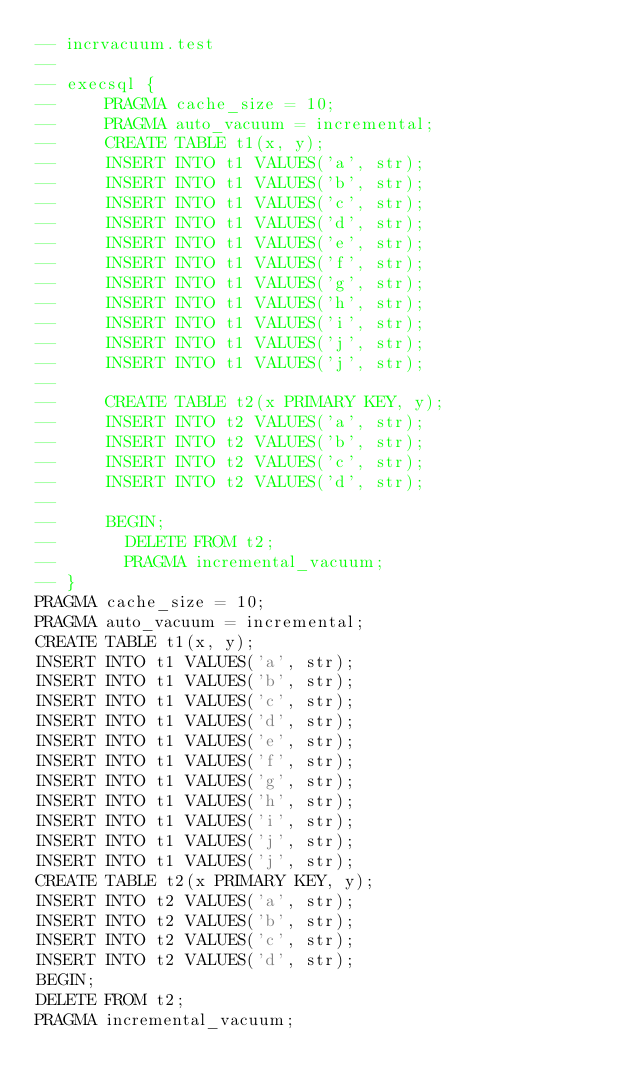<code> <loc_0><loc_0><loc_500><loc_500><_SQL_>-- incrvacuum.test
-- 
-- execsql {
--     PRAGMA cache_size = 10;
--     PRAGMA auto_vacuum = incremental;
--     CREATE TABLE t1(x, y);
--     INSERT INTO t1 VALUES('a', str);
--     INSERT INTO t1 VALUES('b', str);
--     INSERT INTO t1 VALUES('c', str);
--     INSERT INTO t1 VALUES('d', str);
--     INSERT INTO t1 VALUES('e', str);
--     INSERT INTO t1 VALUES('f', str);
--     INSERT INTO t1 VALUES('g', str);
--     INSERT INTO t1 VALUES('h', str);
--     INSERT INTO t1 VALUES('i', str);
--     INSERT INTO t1 VALUES('j', str);
--     INSERT INTO t1 VALUES('j', str);
-- 
--     CREATE TABLE t2(x PRIMARY KEY, y);
--     INSERT INTO t2 VALUES('a', str);
--     INSERT INTO t2 VALUES('b', str);
--     INSERT INTO t2 VALUES('c', str);
--     INSERT INTO t2 VALUES('d', str);
-- 
--     BEGIN;
--       DELETE FROM t2;
--       PRAGMA incremental_vacuum;
-- }
PRAGMA cache_size = 10;
PRAGMA auto_vacuum = incremental;
CREATE TABLE t1(x, y);
INSERT INTO t1 VALUES('a', str);
INSERT INTO t1 VALUES('b', str);
INSERT INTO t1 VALUES('c', str);
INSERT INTO t1 VALUES('d', str);
INSERT INTO t1 VALUES('e', str);
INSERT INTO t1 VALUES('f', str);
INSERT INTO t1 VALUES('g', str);
INSERT INTO t1 VALUES('h', str);
INSERT INTO t1 VALUES('i', str);
INSERT INTO t1 VALUES('j', str);
INSERT INTO t1 VALUES('j', str);
CREATE TABLE t2(x PRIMARY KEY, y);
INSERT INTO t2 VALUES('a', str);
INSERT INTO t2 VALUES('b', str);
INSERT INTO t2 VALUES('c', str);
INSERT INTO t2 VALUES('d', str);
BEGIN;
DELETE FROM t2;
PRAGMA incremental_vacuum;
</code> 